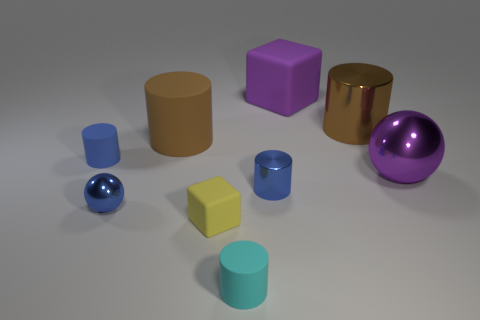The yellow thing is what size?
Your answer should be very brief. Small. Is the color of the big matte block the same as the ball on the right side of the yellow rubber object?
Your response must be concise. Yes. There is a blue rubber object that is the same shape as the small cyan thing; what size is it?
Offer a very short reply. Small. What size is the thing that is the same color as the large cube?
Your answer should be compact. Large. What shape is the purple thing that is in front of the cylinder to the right of the large matte cube?
Give a very brief answer. Sphere. There is a big thing that is right of the large metal thing left of the big purple shiny object; are there any big purple shiny things that are to the right of it?
Your response must be concise. No. What color is the metal object that is the same size as the blue metal cylinder?
Give a very brief answer. Blue. There is a matte thing that is both behind the big purple metallic sphere and right of the brown matte cylinder; what shape is it?
Ensure brevity in your answer.  Cube. There is a matte cube that is behind the metallic sphere that is on the right side of the small yellow cube; how big is it?
Ensure brevity in your answer.  Large. What number of other cylinders are the same color as the big shiny cylinder?
Your answer should be very brief. 1. 